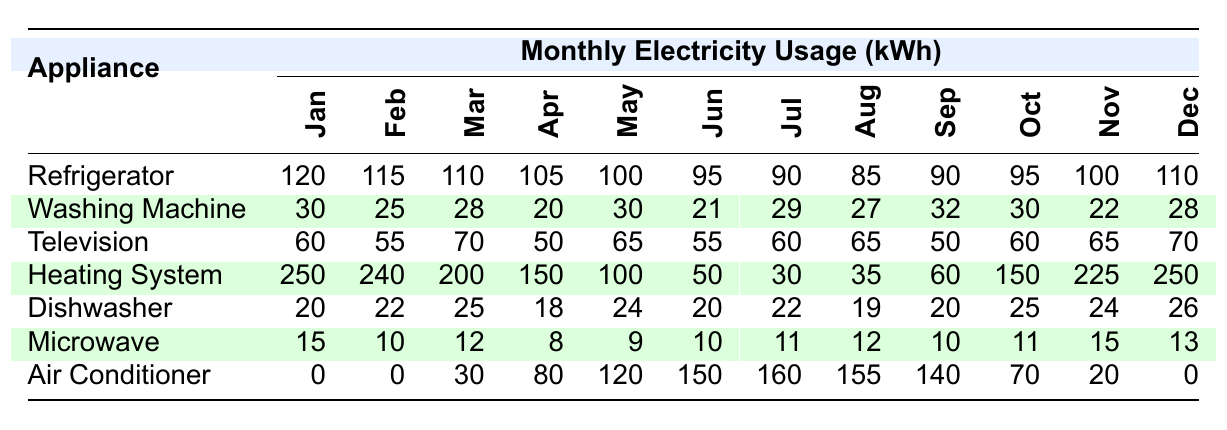What is the monthly electricity usage of the refrigerator in December? According to the table, the refrigerator's usage in December is listed directly as 110 kWh.
Answer: 110 kWh Which month shows the highest electricity usage for the heating system? By reviewing the heating system's usage for each month, the highest value is 250 kWh in January and December.
Answer: January and December What is the average electricity usage of the washing machine over the year? The washing machine's monthly usage values are (30 + 25 + 28 + 20 + 30 + 21 + 29 + 27 + 32 + 30 + 22 + 28) =  306 kWh. There are 12 months, so the average is 306 / 12 = 25.5 kWh.
Answer: 25.5 kWh Did the air conditioner usage exceed 100 kWh at any point in the months listed? Looking at the table, the air conditioner's usage was over 100 kWh in May (120 kWh), June (150 kWh), July (160 kWh), and August (155 kWh).
Answer: Yes What is the difference in electricity usage for the microwave between January and April? The microwave used 15 kWh in January and 8 kWh in April. The difference is 15 - 8 = 7 kWh.
Answer: 7 kWh In which month does the television usage reach its lowest point? The television's monthly usage ranges from 50 kWh to 70 kWh, with the lowest recorded usage being 50 kWh in both April and September.
Answer: April and September What total electricity usage does the dishwasher account for from January to June? The monthly usages are as follows: (20 + 22 + 25 + 18 + 24 + 20) = 129 kWh for the first six months.
Answer: 129 kWh What percentage of the total monthly electricity usage does the air conditioner account for in July? In July, the air conditioner used 160 kWh. First, we find the total usage that month: 90 + 29 + 60 + 30 + 22 + 11 + 160 = 402 kWh. The percentage is (160 / 402) * 100 = 39.8%.
Answer: 39.8% What is the trend of electricity usage for the heating system over the months? Observing the values for the heating system from January to December shows a general decrease in usage peaking at 250 kWh in January, decreasing steadily to around 150 kWh in October, then rising again to 250 kWh in December.
Answer: Decreasing trend, then rising in December Which appliance had the most consistent monthly usage throughout the year? The microwave shows varying usage, but the washing machine has the least variation with values between 20 kWh and 32 kWh, making it relatively consistent compared to others.
Answer: Washing Machine 